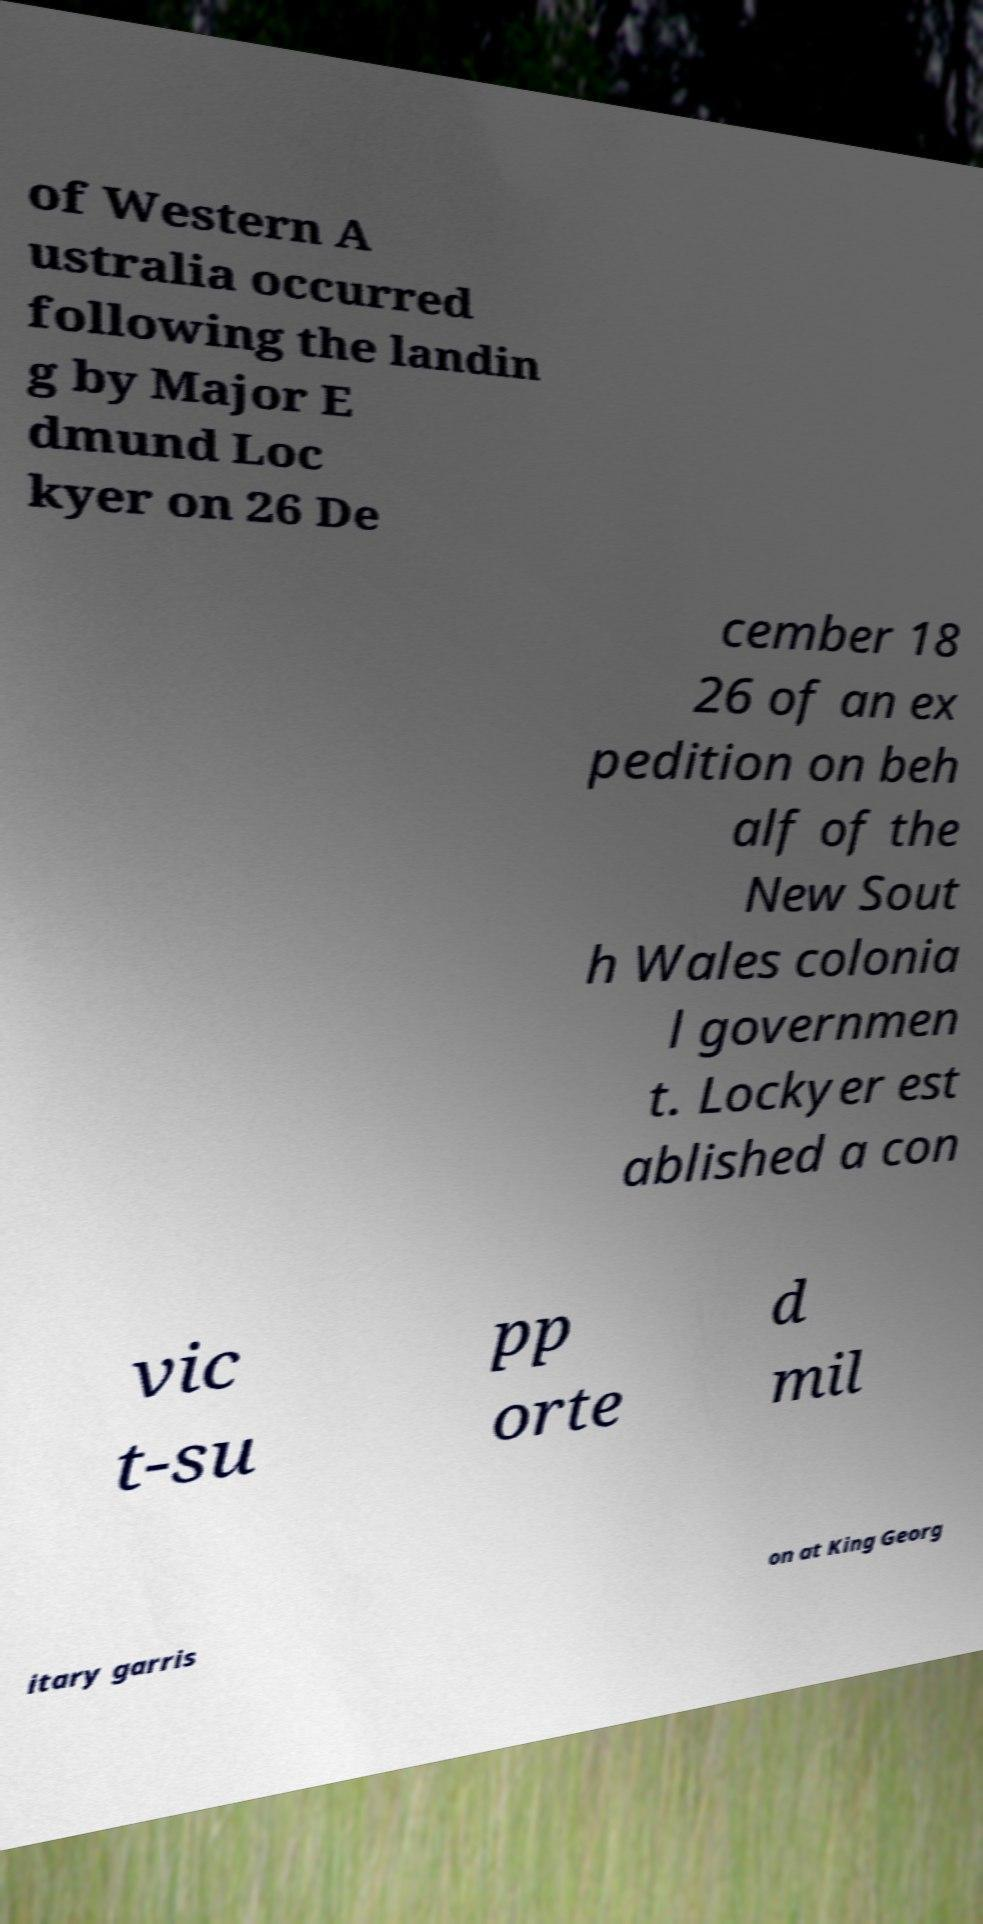Can you read and provide the text displayed in the image?This photo seems to have some interesting text. Can you extract and type it out for me? of Western A ustralia occurred following the landin g by Major E dmund Loc kyer on 26 De cember 18 26 of an ex pedition on beh alf of the New Sout h Wales colonia l governmen t. Lockyer est ablished a con vic t-su pp orte d mil itary garris on at King Georg 